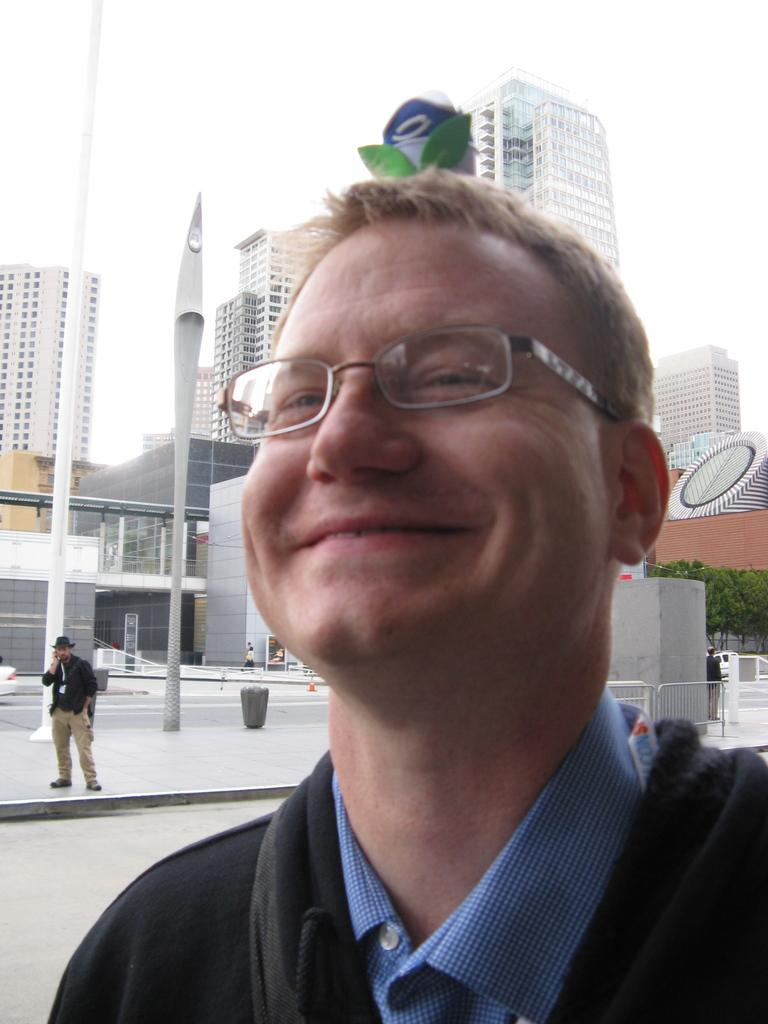What is the expression of the person in the image? There is a person with a smile in the image. What can be seen in the distance behind the person? There are buildings and trees in the background of the image. Can you describe the second person in the image? There is another person standing in front of the buildings. What book is the person holding in the image? There is no book present in the image. How many arms does the cart have in the image? There is no cart present in the image. 